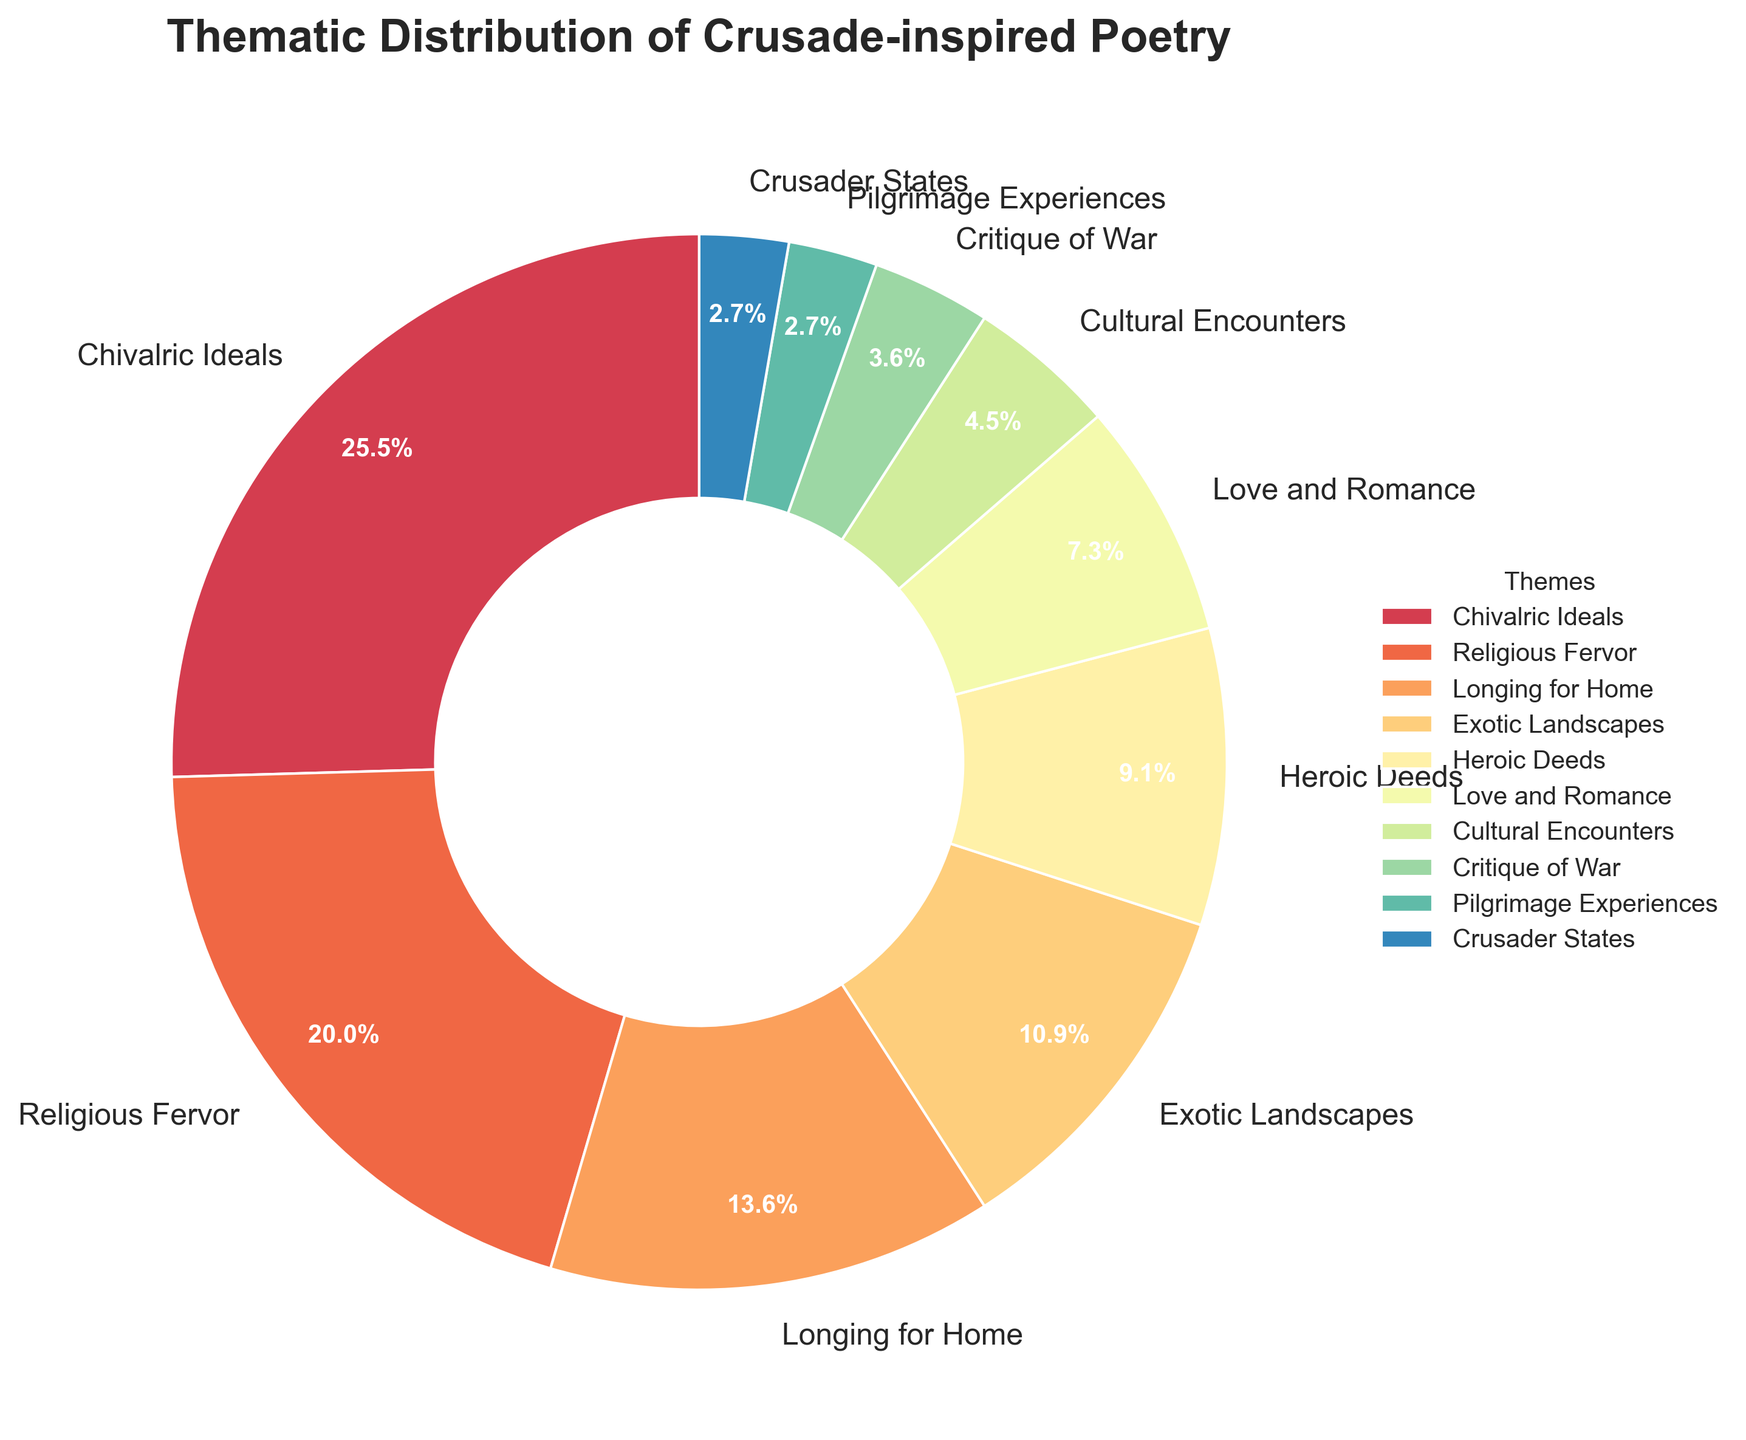What theme has the highest percentage in the pie chart? The pie chart shows multiple themes with their respective percentages. The theme with the highest percentage is located at the top of the label list, which is "Chivalric Ideals" with 28%.
Answer: Chivalric Ideals How much greater is the percentage of "Chivalric Ideals" compared to "Heroic Deeds"? "Chivalric Ideals" has 28%, and "Heroic Deeds" has 10%. The difference between them is 28% - 10%.
Answer: 18% Which theme has the smallest percentage in the pie chart? By examining the pie chart's segment labels and their percentages, the smallest percentage is associated with "Crusader States," "Pilgrimage Experiences," and "Critique of War," each having 3%, 3%, and 4% respectively. Since 3% is the smallest value, "Crusader States" and "Pilgrimage Experiences" share the smallest percentage.
Answer: Crusader States and Pilgrimage Experiences What is the combined percentage of "Religious Fervor" and "Exotic Landscapes"? The percentage of "Religious Fervor" is 22%, and "Exotic Landscapes" is 12%. Adding these together gives 22% + 12%.
Answer: 34% Is the sum of the percentages of "Critique of War" and "Cultural Encounters" more or less than 10%? The percentage of "Critique of War" is 4%, and "Cultural Encounters" is 5%. Summing these gives 4% + 5% = 9%, which is less than 10%.
Answer: Less Which theme is visually the lightest in color? The theme with the lightest color in the pie chart, which uses a spectral colormap, appears to be "Love and Romance."
Answer: Love and Romance What is the average percentage of all themes on the pie chart? To find the average, sum all percentages and divide by the number of themes: (28 + 22 + 15 + 12 + 10 + 8 + 5 + 4 + 3 + 3) / 10 = 110 / 10.
Answer: 11% Which theme between "Love and Romance" and "Longing for Home" has a larger percentage and by how much? The percentage of "Love and Romance" is 8%, and "Longing for Home" is 15%. The difference between them is 15% - 8%.
Answer: Longing for Home by 7% What percentage of themes has a percentage equal to or less than 10%? Categorizing the percentages: "Heroic Deeds" (10%), "Love and Romance" (8%), "Cultural Encounters" (5%), "Critique of War" (4%), "Pilgrimage Experiences" (3%), and "Crusader States" (3%) all have values equal to or less than 10%. There are 6 such themes out of the total 10 themes.
Answer: 60% 